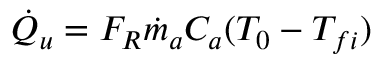Convert formula to latex. <formula><loc_0><loc_0><loc_500><loc_500>\begin{array} { r } { { \dot { Q } } _ { u } = F _ { R } { \dot { m } } _ { a } C _ { a } ( T _ { 0 } - T _ { f i } ) } \end{array}</formula> 